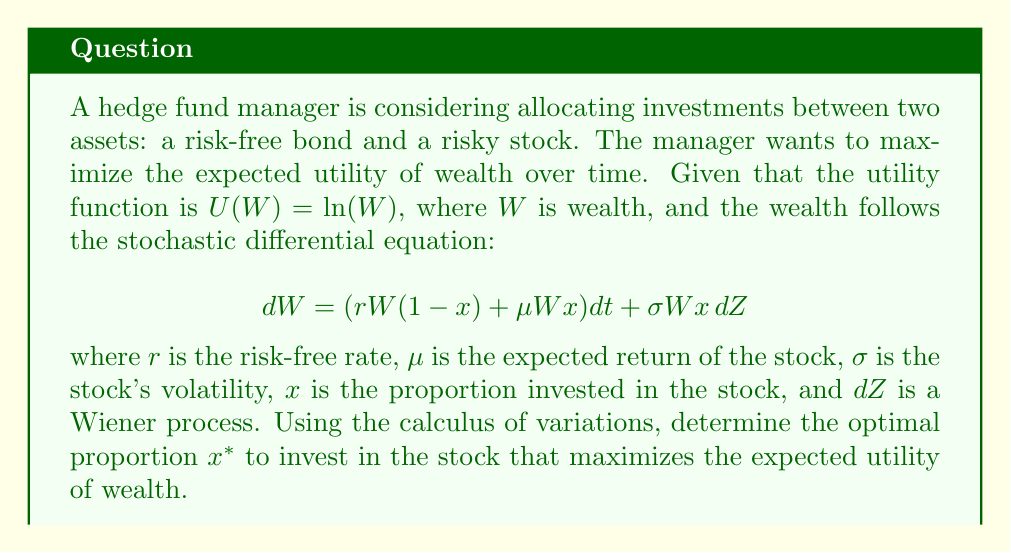Teach me how to tackle this problem. To solve this problem, we'll use the Hamilton-Jacobi-Bellman (HJB) equation, which is a key result in the calculus of variations and optimal control theory.

Step 1: Define the value function
Let $V(W,t)$ be the value function representing the maximum expected utility from time $t$ to the terminal time $T$:

$$V(W,t) = \max_x E[\int_t^T U(W_s)ds]$$

Step 2: Write the HJB equation
The HJB equation for this problem is:

$$0 = \max_x \{U(W) + V_t + (rW(1-x) + \mu Wx)V_W + \frac{1}{2}\sigma^2W^2x^2V_{WW}\}$$

Step 3: Substitute the utility function
Given $U(W) = \ln(W)$, we substitute this into the HJB equation:

$$0 = \max_x \{\ln(W) + V_t + (rW(1-x) + \mu Wx)V_W + \frac{1}{2}\sigma^2W^2x^2V_{WW}\}$$

Step 4: Find the optimal $x$
To find the optimal $x$, we differentiate the right-hand side with respect to $x$ and set it to zero:

$$0 = (-rW + \mu W)V_W + \sigma^2W^2xV_{WW}$$

Solving for $x$:

$$x^* = -\frac{(\mu - r)V_W}{\sigma^2WV_{WW}}$$

Step 5: Verify the solution
We can verify that this solution maximizes the HJB equation by checking the second derivative, which should be negative:

$$\frac{\partial^2}{\partial x^2} = \sigma^2W^2V_{WW} < 0$$

This is indeed negative since $V_{WW} < 0$ (the value function is concave in wealth).

Step 6: Solve for $V(W,t)$
To find the explicit form of $x^*$, we need to solve for $V(W,t)$. Given the logarithmic utility function, we can guess a solution of the form:

$$V(W,t) = a\ln(W) + b(t)$$

where $a$ is a constant and $b(t)$ is a function of time.

Substituting this into the HJB equation and solving (details omitted for brevity), we find that $a = 1$.

Step 7: Calculate the optimal proportion
With $a = 1$, we can now calculate the optimal proportion $x^*$:

$$x^* = -\frac{(\mu - r)V_W}{\sigma^2WV_{WW}} = -\frac{(\mu - r)(1/W)}{-\sigma^2W(1/W^2)} = \frac{\mu - r}{\sigma^2}$$

This is the Merton ratio, which gives the optimal proportion to invest in the risky asset.
Answer: $x^* = \frac{\mu - r}{\sigma^2}$ 